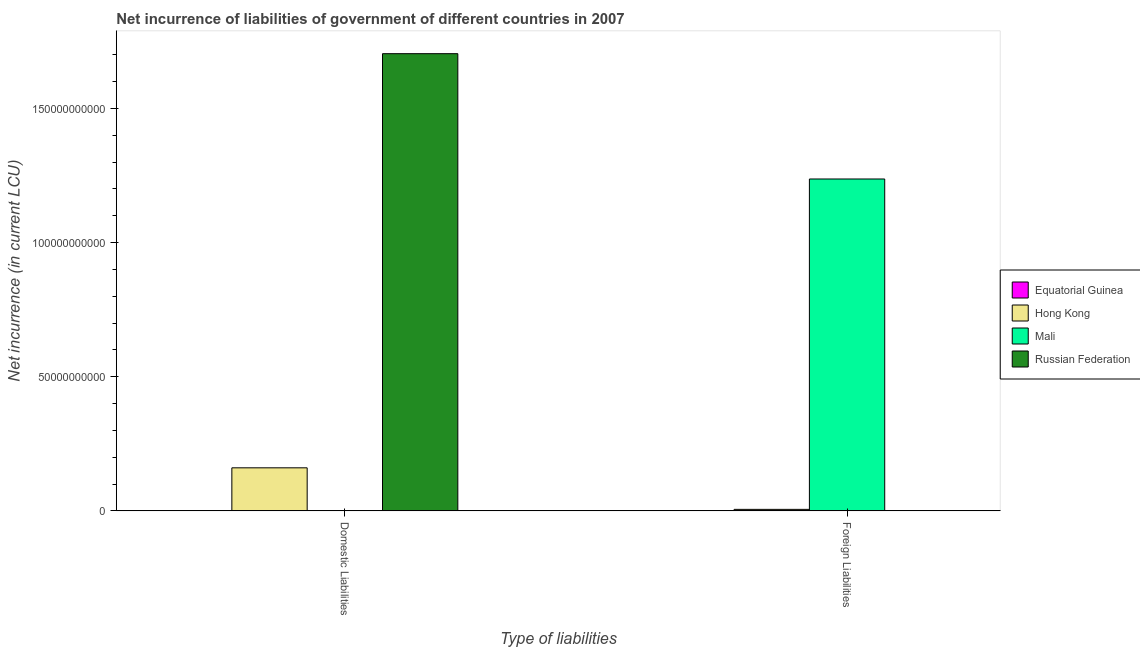How many different coloured bars are there?
Your answer should be compact. 3. How many bars are there on the 1st tick from the left?
Provide a short and direct response. 2. How many bars are there on the 1st tick from the right?
Make the answer very short. 2. What is the label of the 1st group of bars from the left?
Your answer should be very brief. Domestic Liabilities. What is the net incurrence of foreign liabilities in Hong Kong?
Your response must be concise. 5.70e+08. Across all countries, what is the maximum net incurrence of domestic liabilities?
Ensure brevity in your answer.  1.70e+11. Across all countries, what is the minimum net incurrence of domestic liabilities?
Offer a terse response. 0. In which country was the net incurrence of domestic liabilities maximum?
Your answer should be very brief. Russian Federation. What is the total net incurrence of domestic liabilities in the graph?
Provide a succinct answer. 1.86e+11. What is the difference between the net incurrence of domestic liabilities in Russian Federation and that in Hong Kong?
Make the answer very short. 1.54e+11. What is the difference between the net incurrence of foreign liabilities in Equatorial Guinea and the net incurrence of domestic liabilities in Hong Kong?
Make the answer very short. -1.61e+1. What is the average net incurrence of domestic liabilities per country?
Your answer should be very brief. 4.66e+1. What is the difference between the net incurrence of domestic liabilities and net incurrence of foreign liabilities in Hong Kong?
Your answer should be compact. 1.55e+1. In how many countries, is the net incurrence of domestic liabilities greater than 10000000000 LCU?
Provide a succinct answer. 2. What is the ratio of the net incurrence of domestic liabilities in Russian Federation to that in Hong Kong?
Provide a short and direct response. 10.62. In how many countries, is the net incurrence of foreign liabilities greater than the average net incurrence of foreign liabilities taken over all countries?
Your answer should be compact. 1. Are all the bars in the graph horizontal?
Make the answer very short. No. What is the difference between two consecutive major ticks on the Y-axis?
Give a very brief answer. 5.00e+1. Are the values on the major ticks of Y-axis written in scientific E-notation?
Ensure brevity in your answer.  No. Does the graph contain any zero values?
Keep it short and to the point. Yes. What is the title of the graph?
Give a very brief answer. Net incurrence of liabilities of government of different countries in 2007. Does "Pakistan" appear as one of the legend labels in the graph?
Your answer should be very brief. No. What is the label or title of the X-axis?
Provide a short and direct response. Type of liabilities. What is the label or title of the Y-axis?
Offer a terse response. Net incurrence (in current LCU). What is the Net incurrence (in current LCU) of Hong Kong in Domestic Liabilities?
Make the answer very short. 1.61e+1. What is the Net incurrence (in current LCU) in Russian Federation in Domestic Liabilities?
Your response must be concise. 1.70e+11. What is the Net incurrence (in current LCU) in Equatorial Guinea in Foreign Liabilities?
Keep it short and to the point. 0. What is the Net incurrence (in current LCU) in Hong Kong in Foreign Liabilities?
Your response must be concise. 5.70e+08. What is the Net incurrence (in current LCU) of Mali in Foreign Liabilities?
Your response must be concise. 1.24e+11. Across all Type of liabilities, what is the maximum Net incurrence (in current LCU) of Hong Kong?
Your answer should be very brief. 1.61e+1. Across all Type of liabilities, what is the maximum Net incurrence (in current LCU) of Mali?
Make the answer very short. 1.24e+11. Across all Type of liabilities, what is the maximum Net incurrence (in current LCU) of Russian Federation?
Keep it short and to the point. 1.70e+11. Across all Type of liabilities, what is the minimum Net incurrence (in current LCU) of Hong Kong?
Offer a terse response. 5.70e+08. Across all Type of liabilities, what is the minimum Net incurrence (in current LCU) in Mali?
Provide a succinct answer. 0. Across all Type of liabilities, what is the minimum Net incurrence (in current LCU) in Russian Federation?
Offer a very short reply. 0. What is the total Net incurrence (in current LCU) in Hong Kong in the graph?
Make the answer very short. 1.66e+1. What is the total Net incurrence (in current LCU) in Mali in the graph?
Your answer should be compact. 1.24e+11. What is the total Net incurrence (in current LCU) in Russian Federation in the graph?
Offer a terse response. 1.70e+11. What is the difference between the Net incurrence (in current LCU) of Hong Kong in Domestic Liabilities and that in Foreign Liabilities?
Provide a succinct answer. 1.55e+1. What is the difference between the Net incurrence (in current LCU) in Hong Kong in Domestic Liabilities and the Net incurrence (in current LCU) in Mali in Foreign Liabilities?
Your response must be concise. -1.08e+11. What is the average Net incurrence (in current LCU) in Hong Kong per Type of liabilities?
Ensure brevity in your answer.  8.31e+09. What is the average Net incurrence (in current LCU) of Mali per Type of liabilities?
Your response must be concise. 6.18e+1. What is the average Net incurrence (in current LCU) of Russian Federation per Type of liabilities?
Your response must be concise. 8.52e+1. What is the difference between the Net incurrence (in current LCU) of Hong Kong and Net incurrence (in current LCU) of Russian Federation in Domestic Liabilities?
Give a very brief answer. -1.54e+11. What is the difference between the Net incurrence (in current LCU) in Hong Kong and Net incurrence (in current LCU) in Mali in Foreign Liabilities?
Your answer should be very brief. -1.23e+11. What is the ratio of the Net incurrence (in current LCU) of Hong Kong in Domestic Liabilities to that in Foreign Liabilities?
Keep it short and to the point. 28.16. What is the difference between the highest and the second highest Net incurrence (in current LCU) of Hong Kong?
Your answer should be compact. 1.55e+1. What is the difference between the highest and the lowest Net incurrence (in current LCU) in Hong Kong?
Keep it short and to the point. 1.55e+1. What is the difference between the highest and the lowest Net incurrence (in current LCU) in Mali?
Offer a terse response. 1.24e+11. What is the difference between the highest and the lowest Net incurrence (in current LCU) of Russian Federation?
Offer a terse response. 1.70e+11. 